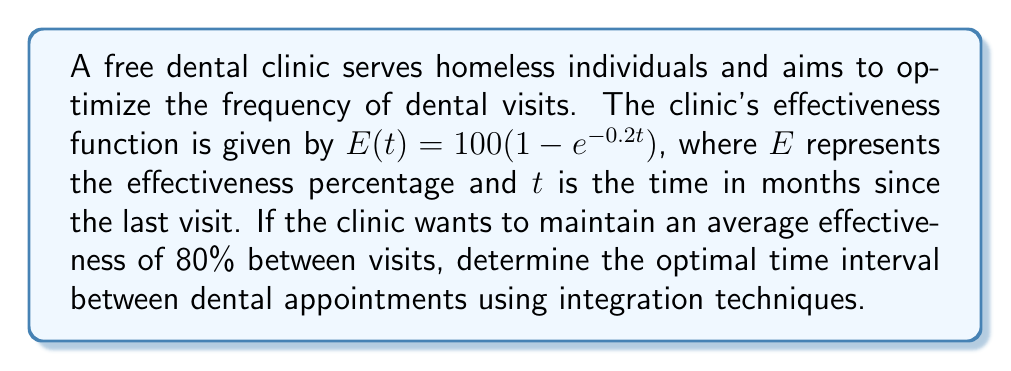Provide a solution to this math problem. To solve this problem, we'll follow these steps:

1) The average effectiveness over time $T$ is given by:

   $$\frac{1}{T} \int_0^T E(t) dt = 80$$

2) Substituting the given function:

   $$\frac{1}{T} \int_0^T 100(1 - e^{-0.2t}) dt = 80$$

3) Evaluate the integral:

   $$\frac{1}{T} [100t + 500e^{-0.2t}]_0^T = 80$$

4) Simplify:

   $$\frac{1}{T} [100T + 500e^{-0.2T} - 500] = 80$$

5) Multiply both sides by $T$:

   $$100T + 500e^{-0.2T} - 500 = 80T$$

6) Rearrange:

   $$500e^{-0.2T} = 80T - 100T + 500$$
   $$500e^{-0.2T} = 500 - 20T$$

7) Divide both sides by 500:

   $$e^{-0.2T} = 1 - 0.04T$$

8) Take natural log of both sides:

   $$-0.2T = \ln(1 - 0.04T)$$

9) This equation cannot be solved algebraically. We need to use numerical methods or graphical solutions to find $T$. Using a numerical solver, we find:

   $$T \approx 6.93$$

Therefore, the optimal time interval between dental appointments is approximately 6.93 months.
Answer: 6.93 months 